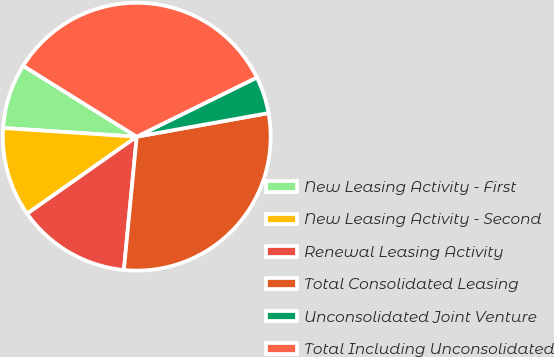Convert chart to OTSL. <chart><loc_0><loc_0><loc_500><loc_500><pie_chart><fcel>New Leasing Activity - First<fcel>New Leasing Activity - Second<fcel>Renewal Leasing Activity<fcel>Total Consolidated Leasing<fcel>Unconsolidated Joint Venture<fcel>Total Including Unconsolidated<nl><fcel>7.85%<fcel>10.78%<fcel>13.72%<fcel>29.35%<fcel>4.47%<fcel>33.82%<nl></chart> 